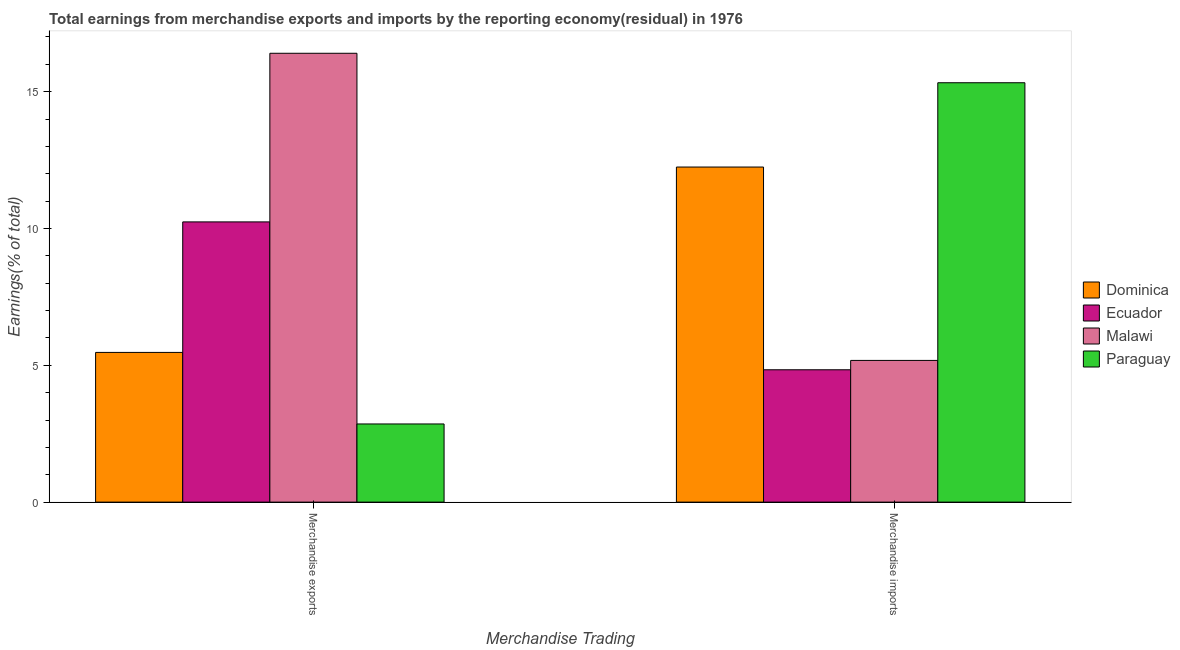How many groups of bars are there?
Ensure brevity in your answer.  2. Are the number of bars per tick equal to the number of legend labels?
Provide a short and direct response. Yes. Are the number of bars on each tick of the X-axis equal?
Your answer should be compact. Yes. What is the label of the 2nd group of bars from the left?
Your response must be concise. Merchandise imports. What is the earnings from merchandise exports in Dominica?
Your answer should be compact. 5.47. Across all countries, what is the maximum earnings from merchandise imports?
Your response must be concise. 15.33. Across all countries, what is the minimum earnings from merchandise imports?
Provide a succinct answer. 4.84. In which country was the earnings from merchandise exports maximum?
Provide a short and direct response. Malawi. In which country was the earnings from merchandise imports minimum?
Offer a terse response. Ecuador. What is the total earnings from merchandise exports in the graph?
Offer a very short reply. 34.97. What is the difference between the earnings from merchandise imports in Malawi and that in Paraguay?
Ensure brevity in your answer.  -10.15. What is the difference between the earnings from merchandise exports in Dominica and the earnings from merchandise imports in Malawi?
Offer a very short reply. 0.29. What is the average earnings from merchandise exports per country?
Give a very brief answer. 8.74. What is the difference between the earnings from merchandise exports and earnings from merchandise imports in Paraguay?
Offer a terse response. -12.47. What is the ratio of the earnings from merchandise exports in Dominica to that in Paraguay?
Your response must be concise. 1.92. Is the earnings from merchandise imports in Dominica less than that in Malawi?
Keep it short and to the point. No. In how many countries, is the earnings from merchandise exports greater than the average earnings from merchandise exports taken over all countries?
Offer a very short reply. 2. What does the 4th bar from the left in Merchandise exports represents?
Provide a succinct answer. Paraguay. What does the 3rd bar from the right in Merchandise exports represents?
Offer a terse response. Ecuador. How many bars are there?
Your answer should be very brief. 8. Are all the bars in the graph horizontal?
Give a very brief answer. No. How many countries are there in the graph?
Offer a very short reply. 4. What is the difference between two consecutive major ticks on the Y-axis?
Provide a succinct answer. 5. Are the values on the major ticks of Y-axis written in scientific E-notation?
Offer a terse response. No. Does the graph contain any zero values?
Your response must be concise. No. Does the graph contain grids?
Give a very brief answer. No. What is the title of the graph?
Keep it short and to the point. Total earnings from merchandise exports and imports by the reporting economy(residual) in 1976. What is the label or title of the X-axis?
Ensure brevity in your answer.  Merchandise Trading. What is the label or title of the Y-axis?
Offer a very short reply. Earnings(% of total). What is the Earnings(% of total) in Dominica in Merchandise exports?
Offer a terse response. 5.47. What is the Earnings(% of total) of Ecuador in Merchandise exports?
Your response must be concise. 10.24. What is the Earnings(% of total) in Malawi in Merchandise exports?
Ensure brevity in your answer.  16.4. What is the Earnings(% of total) of Paraguay in Merchandise exports?
Provide a succinct answer. 2.86. What is the Earnings(% of total) of Dominica in Merchandise imports?
Provide a succinct answer. 12.25. What is the Earnings(% of total) in Ecuador in Merchandise imports?
Your answer should be very brief. 4.84. What is the Earnings(% of total) in Malawi in Merchandise imports?
Provide a succinct answer. 5.18. What is the Earnings(% of total) in Paraguay in Merchandise imports?
Provide a succinct answer. 15.33. Across all Merchandise Trading, what is the maximum Earnings(% of total) in Dominica?
Your answer should be very brief. 12.25. Across all Merchandise Trading, what is the maximum Earnings(% of total) in Ecuador?
Your answer should be very brief. 10.24. Across all Merchandise Trading, what is the maximum Earnings(% of total) in Malawi?
Your answer should be compact. 16.4. Across all Merchandise Trading, what is the maximum Earnings(% of total) of Paraguay?
Ensure brevity in your answer.  15.33. Across all Merchandise Trading, what is the minimum Earnings(% of total) of Dominica?
Your answer should be very brief. 5.47. Across all Merchandise Trading, what is the minimum Earnings(% of total) in Ecuador?
Provide a short and direct response. 4.84. Across all Merchandise Trading, what is the minimum Earnings(% of total) of Malawi?
Give a very brief answer. 5.18. Across all Merchandise Trading, what is the minimum Earnings(% of total) of Paraguay?
Provide a succinct answer. 2.86. What is the total Earnings(% of total) in Dominica in the graph?
Provide a short and direct response. 17.72. What is the total Earnings(% of total) of Ecuador in the graph?
Provide a succinct answer. 15.08. What is the total Earnings(% of total) of Malawi in the graph?
Provide a succinct answer. 21.58. What is the total Earnings(% of total) in Paraguay in the graph?
Your answer should be compact. 18.18. What is the difference between the Earnings(% of total) of Dominica in Merchandise exports and that in Merchandise imports?
Keep it short and to the point. -6.77. What is the difference between the Earnings(% of total) of Ecuador in Merchandise exports and that in Merchandise imports?
Make the answer very short. 5.4. What is the difference between the Earnings(% of total) of Malawi in Merchandise exports and that in Merchandise imports?
Make the answer very short. 11.22. What is the difference between the Earnings(% of total) in Paraguay in Merchandise exports and that in Merchandise imports?
Make the answer very short. -12.47. What is the difference between the Earnings(% of total) in Dominica in Merchandise exports and the Earnings(% of total) in Ecuador in Merchandise imports?
Provide a succinct answer. 0.63. What is the difference between the Earnings(% of total) in Dominica in Merchandise exports and the Earnings(% of total) in Malawi in Merchandise imports?
Your answer should be compact. 0.29. What is the difference between the Earnings(% of total) in Dominica in Merchandise exports and the Earnings(% of total) in Paraguay in Merchandise imports?
Offer a terse response. -9.85. What is the difference between the Earnings(% of total) in Ecuador in Merchandise exports and the Earnings(% of total) in Malawi in Merchandise imports?
Your answer should be very brief. 5.06. What is the difference between the Earnings(% of total) in Ecuador in Merchandise exports and the Earnings(% of total) in Paraguay in Merchandise imports?
Give a very brief answer. -5.09. What is the difference between the Earnings(% of total) in Malawi in Merchandise exports and the Earnings(% of total) in Paraguay in Merchandise imports?
Provide a short and direct response. 1.08. What is the average Earnings(% of total) in Dominica per Merchandise Trading?
Your answer should be very brief. 8.86. What is the average Earnings(% of total) of Ecuador per Merchandise Trading?
Make the answer very short. 7.54. What is the average Earnings(% of total) of Malawi per Merchandise Trading?
Your answer should be very brief. 10.79. What is the average Earnings(% of total) in Paraguay per Merchandise Trading?
Keep it short and to the point. 9.09. What is the difference between the Earnings(% of total) in Dominica and Earnings(% of total) in Ecuador in Merchandise exports?
Provide a short and direct response. -4.77. What is the difference between the Earnings(% of total) of Dominica and Earnings(% of total) of Malawi in Merchandise exports?
Your response must be concise. -10.93. What is the difference between the Earnings(% of total) in Dominica and Earnings(% of total) in Paraguay in Merchandise exports?
Ensure brevity in your answer.  2.61. What is the difference between the Earnings(% of total) in Ecuador and Earnings(% of total) in Malawi in Merchandise exports?
Provide a short and direct response. -6.16. What is the difference between the Earnings(% of total) in Ecuador and Earnings(% of total) in Paraguay in Merchandise exports?
Provide a succinct answer. 7.38. What is the difference between the Earnings(% of total) in Malawi and Earnings(% of total) in Paraguay in Merchandise exports?
Offer a very short reply. 13.55. What is the difference between the Earnings(% of total) of Dominica and Earnings(% of total) of Ecuador in Merchandise imports?
Your answer should be compact. 7.41. What is the difference between the Earnings(% of total) in Dominica and Earnings(% of total) in Malawi in Merchandise imports?
Offer a terse response. 7.07. What is the difference between the Earnings(% of total) of Dominica and Earnings(% of total) of Paraguay in Merchandise imports?
Ensure brevity in your answer.  -3.08. What is the difference between the Earnings(% of total) in Ecuador and Earnings(% of total) in Malawi in Merchandise imports?
Your answer should be compact. -0.34. What is the difference between the Earnings(% of total) of Ecuador and Earnings(% of total) of Paraguay in Merchandise imports?
Make the answer very short. -10.49. What is the difference between the Earnings(% of total) of Malawi and Earnings(% of total) of Paraguay in Merchandise imports?
Make the answer very short. -10.15. What is the ratio of the Earnings(% of total) of Dominica in Merchandise exports to that in Merchandise imports?
Offer a very short reply. 0.45. What is the ratio of the Earnings(% of total) of Ecuador in Merchandise exports to that in Merchandise imports?
Your answer should be compact. 2.12. What is the ratio of the Earnings(% of total) of Malawi in Merchandise exports to that in Merchandise imports?
Give a very brief answer. 3.17. What is the ratio of the Earnings(% of total) of Paraguay in Merchandise exports to that in Merchandise imports?
Your answer should be compact. 0.19. What is the difference between the highest and the second highest Earnings(% of total) in Dominica?
Your answer should be very brief. 6.77. What is the difference between the highest and the second highest Earnings(% of total) of Ecuador?
Ensure brevity in your answer.  5.4. What is the difference between the highest and the second highest Earnings(% of total) of Malawi?
Your response must be concise. 11.22. What is the difference between the highest and the second highest Earnings(% of total) in Paraguay?
Make the answer very short. 12.47. What is the difference between the highest and the lowest Earnings(% of total) in Dominica?
Your answer should be compact. 6.77. What is the difference between the highest and the lowest Earnings(% of total) in Ecuador?
Provide a succinct answer. 5.4. What is the difference between the highest and the lowest Earnings(% of total) in Malawi?
Ensure brevity in your answer.  11.22. What is the difference between the highest and the lowest Earnings(% of total) in Paraguay?
Make the answer very short. 12.47. 